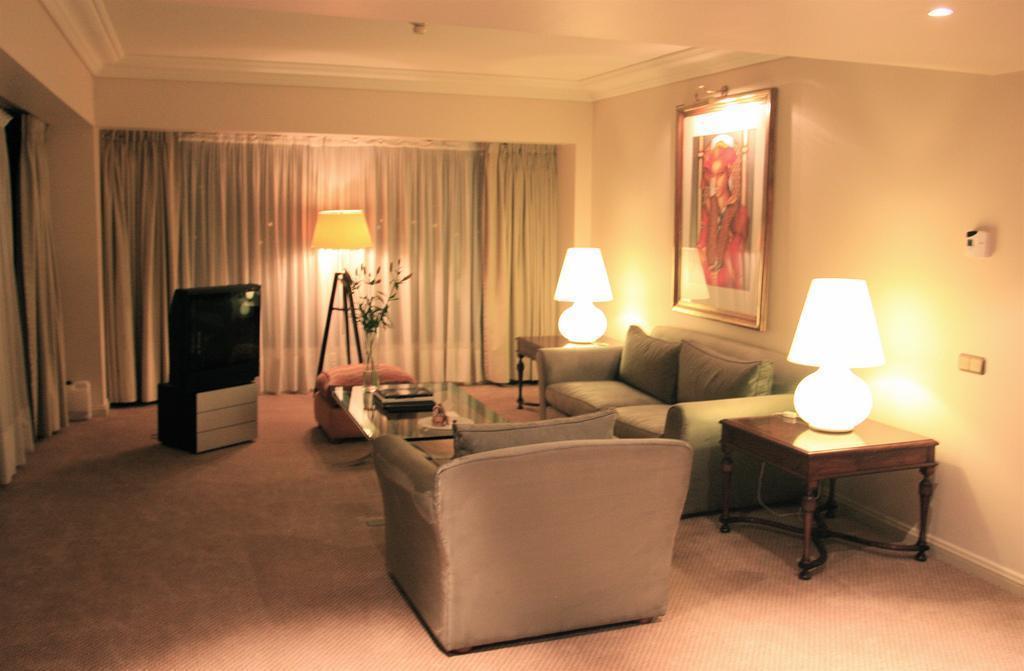How many skateboarders are there?
Give a very brief answer. 1. How many side tables are pictured?
Give a very brief answer. 2. How many matching lamps are shown?
Give a very brief answer. 2. How many drawings are on the wall?
Give a very brief answer. 1. How many lamps are there?
Give a very brief answer. 3. 